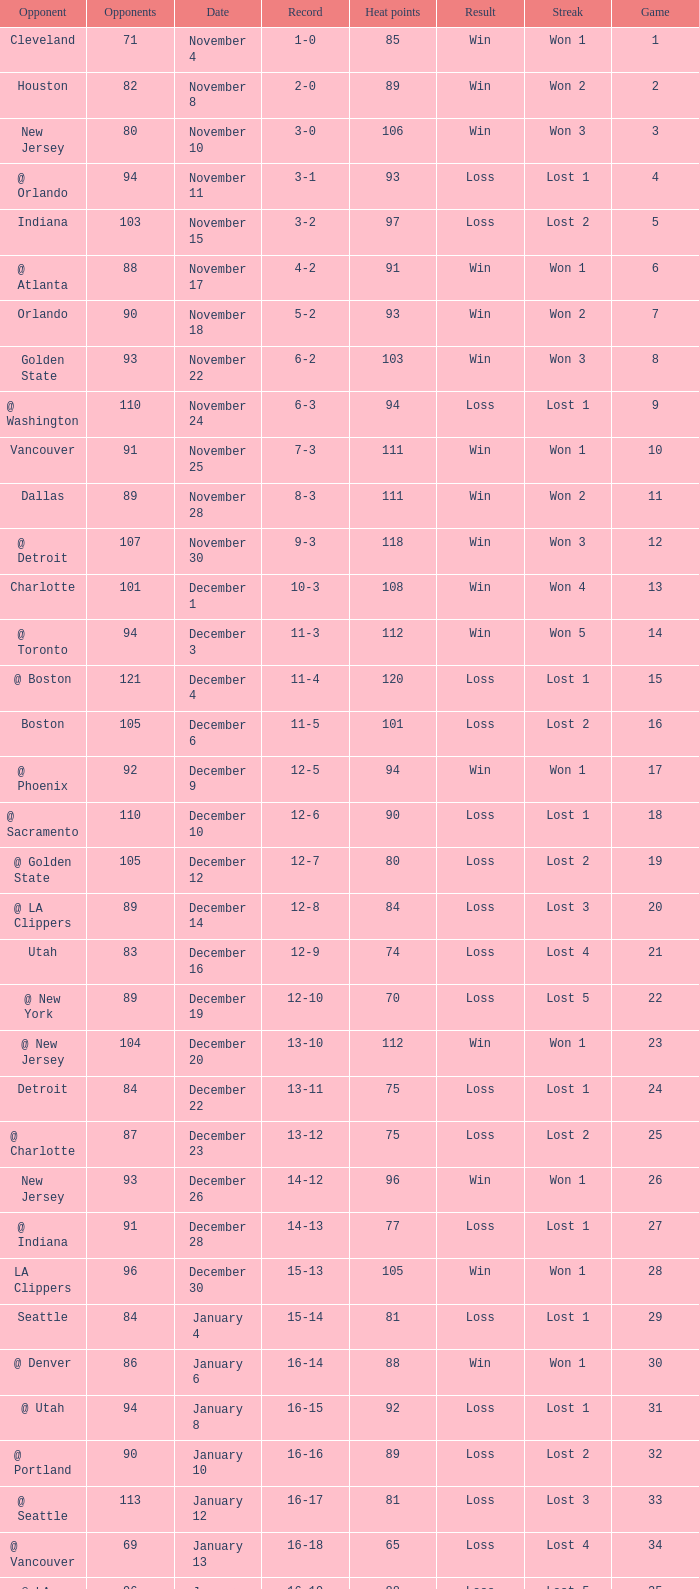What is Heat Points, when Game is less than 80, and when Date is "April 26 (First Round)"? 85.0. 